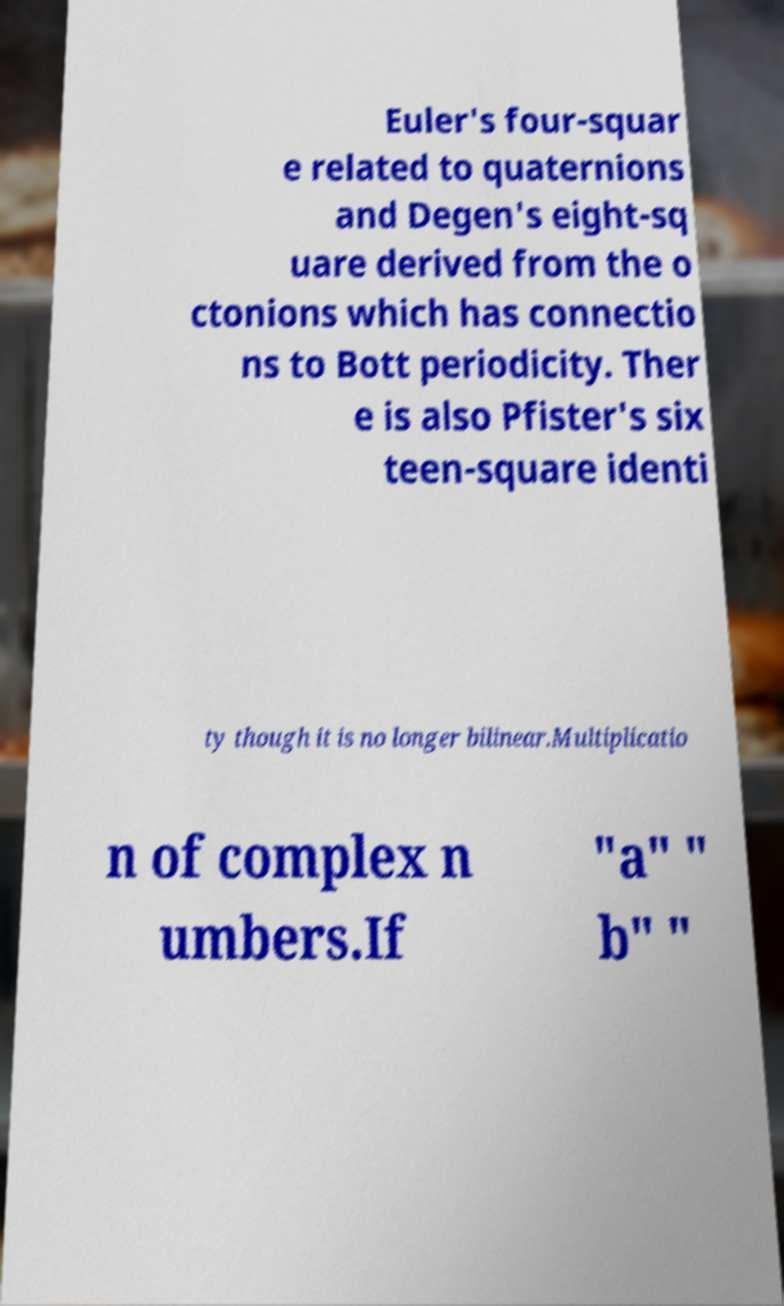Please identify and transcribe the text found in this image. Euler's four-squar e related to quaternions and Degen's eight-sq uare derived from the o ctonions which has connectio ns to Bott periodicity. Ther e is also Pfister's six teen-square identi ty though it is no longer bilinear.Multiplicatio n of complex n umbers.If "a" " b" " 